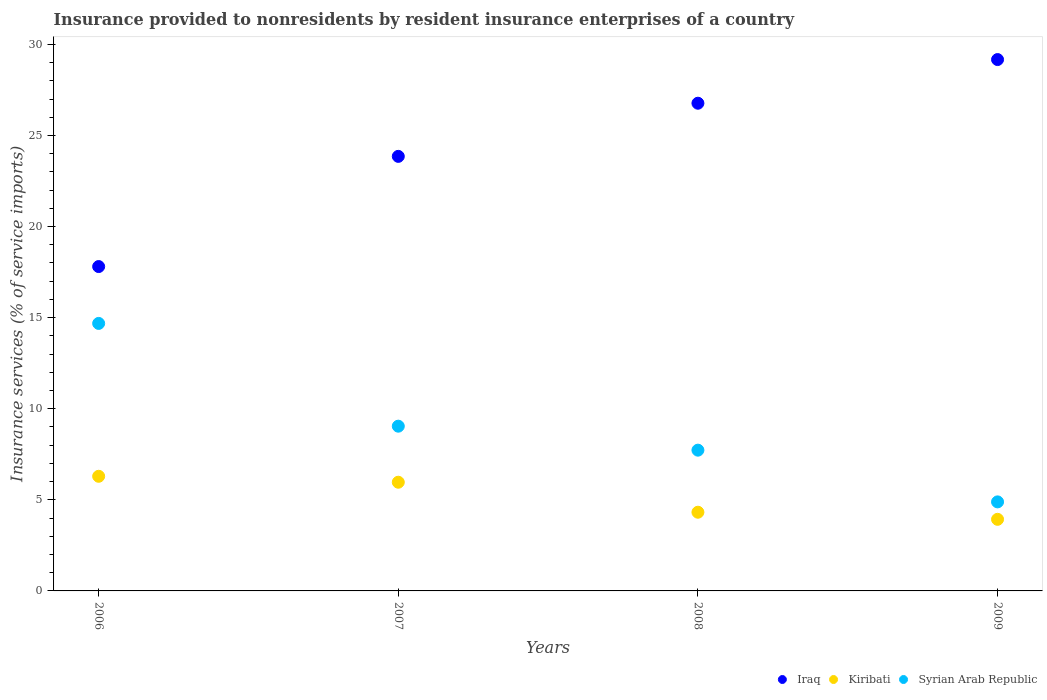How many different coloured dotlines are there?
Keep it short and to the point. 3. What is the insurance provided to nonresidents in Iraq in 2009?
Give a very brief answer. 29.16. Across all years, what is the maximum insurance provided to nonresidents in Syrian Arab Republic?
Make the answer very short. 14.68. Across all years, what is the minimum insurance provided to nonresidents in Iraq?
Ensure brevity in your answer.  17.8. In which year was the insurance provided to nonresidents in Kiribati minimum?
Your answer should be very brief. 2009. What is the total insurance provided to nonresidents in Syrian Arab Republic in the graph?
Provide a short and direct response. 36.34. What is the difference between the insurance provided to nonresidents in Kiribati in 2007 and that in 2008?
Provide a succinct answer. 1.65. What is the difference between the insurance provided to nonresidents in Kiribati in 2007 and the insurance provided to nonresidents in Syrian Arab Republic in 2009?
Provide a succinct answer. 1.08. What is the average insurance provided to nonresidents in Kiribati per year?
Offer a terse response. 5.13. In the year 2006, what is the difference between the insurance provided to nonresidents in Iraq and insurance provided to nonresidents in Syrian Arab Republic?
Your response must be concise. 3.12. What is the ratio of the insurance provided to nonresidents in Kiribati in 2006 to that in 2007?
Offer a terse response. 1.05. Is the insurance provided to nonresidents in Kiribati in 2006 less than that in 2009?
Provide a succinct answer. No. What is the difference between the highest and the second highest insurance provided to nonresidents in Kiribati?
Offer a terse response. 0.33. What is the difference between the highest and the lowest insurance provided to nonresidents in Kiribati?
Keep it short and to the point. 2.36. In how many years, is the insurance provided to nonresidents in Iraq greater than the average insurance provided to nonresidents in Iraq taken over all years?
Ensure brevity in your answer.  2. Is it the case that in every year, the sum of the insurance provided to nonresidents in Iraq and insurance provided to nonresidents in Kiribati  is greater than the insurance provided to nonresidents in Syrian Arab Republic?
Give a very brief answer. Yes. Does the insurance provided to nonresidents in Iraq monotonically increase over the years?
Ensure brevity in your answer.  Yes. How many years are there in the graph?
Keep it short and to the point. 4. Where does the legend appear in the graph?
Offer a very short reply. Bottom right. What is the title of the graph?
Your response must be concise. Insurance provided to nonresidents by resident insurance enterprises of a country. What is the label or title of the Y-axis?
Your response must be concise. Insurance services (% of service imports). What is the Insurance services (% of service imports) of Iraq in 2006?
Make the answer very short. 17.8. What is the Insurance services (% of service imports) in Kiribati in 2006?
Give a very brief answer. 6.29. What is the Insurance services (% of service imports) of Syrian Arab Republic in 2006?
Your answer should be very brief. 14.68. What is the Insurance services (% of service imports) of Iraq in 2007?
Make the answer very short. 23.85. What is the Insurance services (% of service imports) in Kiribati in 2007?
Give a very brief answer. 5.97. What is the Insurance services (% of service imports) in Syrian Arab Republic in 2007?
Your response must be concise. 9.04. What is the Insurance services (% of service imports) in Iraq in 2008?
Make the answer very short. 26.77. What is the Insurance services (% of service imports) of Kiribati in 2008?
Your response must be concise. 4.32. What is the Insurance services (% of service imports) of Syrian Arab Republic in 2008?
Keep it short and to the point. 7.73. What is the Insurance services (% of service imports) of Iraq in 2009?
Make the answer very short. 29.16. What is the Insurance services (% of service imports) of Kiribati in 2009?
Make the answer very short. 3.93. What is the Insurance services (% of service imports) of Syrian Arab Republic in 2009?
Provide a short and direct response. 4.89. Across all years, what is the maximum Insurance services (% of service imports) of Iraq?
Give a very brief answer. 29.16. Across all years, what is the maximum Insurance services (% of service imports) in Kiribati?
Provide a short and direct response. 6.29. Across all years, what is the maximum Insurance services (% of service imports) in Syrian Arab Republic?
Your answer should be compact. 14.68. Across all years, what is the minimum Insurance services (% of service imports) in Iraq?
Provide a short and direct response. 17.8. Across all years, what is the minimum Insurance services (% of service imports) of Kiribati?
Ensure brevity in your answer.  3.93. Across all years, what is the minimum Insurance services (% of service imports) of Syrian Arab Republic?
Make the answer very short. 4.89. What is the total Insurance services (% of service imports) of Iraq in the graph?
Make the answer very short. 97.59. What is the total Insurance services (% of service imports) of Kiribati in the graph?
Your answer should be very brief. 20.51. What is the total Insurance services (% of service imports) in Syrian Arab Republic in the graph?
Your answer should be compact. 36.34. What is the difference between the Insurance services (% of service imports) of Iraq in 2006 and that in 2007?
Your answer should be compact. -6.05. What is the difference between the Insurance services (% of service imports) in Kiribati in 2006 and that in 2007?
Your answer should be very brief. 0.33. What is the difference between the Insurance services (% of service imports) in Syrian Arab Republic in 2006 and that in 2007?
Provide a short and direct response. 5.64. What is the difference between the Insurance services (% of service imports) in Iraq in 2006 and that in 2008?
Give a very brief answer. -8.97. What is the difference between the Insurance services (% of service imports) in Kiribati in 2006 and that in 2008?
Give a very brief answer. 1.97. What is the difference between the Insurance services (% of service imports) of Syrian Arab Republic in 2006 and that in 2008?
Keep it short and to the point. 6.96. What is the difference between the Insurance services (% of service imports) in Iraq in 2006 and that in 2009?
Your response must be concise. -11.36. What is the difference between the Insurance services (% of service imports) of Kiribati in 2006 and that in 2009?
Provide a succinct answer. 2.36. What is the difference between the Insurance services (% of service imports) in Syrian Arab Republic in 2006 and that in 2009?
Keep it short and to the point. 9.8. What is the difference between the Insurance services (% of service imports) in Iraq in 2007 and that in 2008?
Make the answer very short. -2.92. What is the difference between the Insurance services (% of service imports) in Kiribati in 2007 and that in 2008?
Your response must be concise. 1.65. What is the difference between the Insurance services (% of service imports) of Syrian Arab Republic in 2007 and that in 2008?
Offer a very short reply. 1.32. What is the difference between the Insurance services (% of service imports) in Iraq in 2007 and that in 2009?
Offer a very short reply. -5.31. What is the difference between the Insurance services (% of service imports) of Kiribati in 2007 and that in 2009?
Provide a succinct answer. 2.04. What is the difference between the Insurance services (% of service imports) of Syrian Arab Republic in 2007 and that in 2009?
Your answer should be compact. 4.15. What is the difference between the Insurance services (% of service imports) in Iraq in 2008 and that in 2009?
Provide a short and direct response. -2.4. What is the difference between the Insurance services (% of service imports) in Kiribati in 2008 and that in 2009?
Offer a very short reply. 0.39. What is the difference between the Insurance services (% of service imports) in Syrian Arab Republic in 2008 and that in 2009?
Your answer should be very brief. 2.84. What is the difference between the Insurance services (% of service imports) of Iraq in 2006 and the Insurance services (% of service imports) of Kiribati in 2007?
Make the answer very short. 11.84. What is the difference between the Insurance services (% of service imports) of Iraq in 2006 and the Insurance services (% of service imports) of Syrian Arab Republic in 2007?
Offer a very short reply. 8.76. What is the difference between the Insurance services (% of service imports) in Kiribati in 2006 and the Insurance services (% of service imports) in Syrian Arab Republic in 2007?
Your answer should be very brief. -2.75. What is the difference between the Insurance services (% of service imports) in Iraq in 2006 and the Insurance services (% of service imports) in Kiribati in 2008?
Your answer should be compact. 13.48. What is the difference between the Insurance services (% of service imports) of Iraq in 2006 and the Insurance services (% of service imports) of Syrian Arab Republic in 2008?
Offer a terse response. 10.08. What is the difference between the Insurance services (% of service imports) in Kiribati in 2006 and the Insurance services (% of service imports) in Syrian Arab Republic in 2008?
Your response must be concise. -1.43. What is the difference between the Insurance services (% of service imports) of Iraq in 2006 and the Insurance services (% of service imports) of Kiribati in 2009?
Provide a succinct answer. 13.87. What is the difference between the Insurance services (% of service imports) in Iraq in 2006 and the Insurance services (% of service imports) in Syrian Arab Republic in 2009?
Make the answer very short. 12.92. What is the difference between the Insurance services (% of service imports) in Kiribati in 2006 and the Insurance services (% of service imports) in Syrian Arab Republic in 2009?
Keep it short and to the point. 1.4. What is the difference between the Insurance services (% of service imports) of Iraq in 2007 and the Insurance services (% of service imports) of Kiribati in 2008?
Provide a succinct answer. 19.53. What is the difference between the Insurance services (% of service imports) in Iraq in 2007 and the Insurance services (% of service imports) in Syrian Arab Republic in 2008?
Provide a succinct answer. 16.13. What is the difference between the Insurance services (% of service imports) in Kiribati in 2007 and the Insurance services (% of service imports) in Syrian Arab Republic in 2008?
Keep it short and to the point. -1.76. What is the difference between the Insurance services (% of service imports) of Iraq in 2007 and the Insurance services (% of service imports) of Kiribati in 2009?
Provide a short and direct response. 19.92. What is the difference between the Insurance services (% of service imports) of Iraq in 2007 and the Insurance services (% of service imports) of Syrian Arab Republic in 2009?
Your answer should be very brief. 18.96. What is the difference between the Insurance services (% of service imports) in Kiribati in 2007 and the Insurance services (% of service imports) in Syrian Arab Republic in 2009?
Your answer should be compact. 1.08. What is the difference between the Insurance services (% of service imports) in Iraq in 2008 and the Insurance services (% of service imports) in Kiribati in 2009?
Keep it short and to the point. 22.84. What is the difference between the Insurance services (% of service imports) in Iraq in 2008 and the Insurance services (% of service imports) in Syrian Arab Republic in 2009?
Ensure brevity in your answer.  21.88. What is the difference between the Insurance services (% of service imports) of Kiribati in 2008 and the Insurance services (% of service imports) of Syrian Arab Republic in 2009?
Offer a very short reply. -0.57. What is the average Insurance services (% of service imports) of Iraq per year?
Give a very brief answer. 24.4. What is the average Insurance services (% of service imports) in Kiribati per year?
Keep it short and to the point. 5.13. What is the average Insurance services (% of service imports) of Syrian Arab Republic per year?
Provide a succinct answer. 9.08. In the year 2006, what is the difference between the Insurance services (% of service imports) in Iraq and Insurance services (% of service imports) in Kiribati?
Keep it short and to the point. 11.51. In the year 2006, what is the difference between the Insurance services (% of service imports) of Iraq and Insurance services (% of service imports) of Syrian Arab Republic?
Your response must be concise. 3.12. In the year 2006, what is the difference between the Insurance services (% of service imports) in Kiribati and Insurance services (% of service imports) in Syrian Arab Republic?
Give a very brief answer. -8.39. In the year 2007, what is the difference between the Insurance services (% of service imports) of Iraq and Insurance services (% of service imports) of Kiribati?
Give a very brief answer. 17.89. In the year 2007, what is the difference between the Insurance services (% of service imports) in Iraq and Insurance services (% of service imports) in Syrian Arab Republic?
Offer a terse response. 14.81. In the year 2007, what is the difference between the Insurance services (% of service imports) in Kiribati and Insurance services (% of service imports) in Syrian Arab Republic?
Provide a short and direct response. -3.08. In the year 2008, what is the difference between the Insurance services (% of service imports) of Iraq and Insurance services (% of service imports) of Kiribati?
Provide a short and direct response. 22.45. In the year 2008, what is the difference between the Insurance services (% of service imports) in Iraq and Insurance services (% of service imports) in Syrian Arab Republic?
Ensure brevity in your answer.  19.04. In the year 2008, what is the difference between the Insurance services (% of service imports) in Kiribati and Insurance services (% of service imports) in Syrian Arab Republic?
Make the answer very short. -3.41. In the year 2009, what is the difference between the Insurance services (% of service imports) in Iraq and Insurance services (% of service imports) in Kiribati?
Your answer should be very brief. 25.23. In the year 2009, what is the difference between the Insurance services (% of service imports) of Iraq and Insurance services (% of service imports) of Syrian Arab Republic?
Offer a very short reply. 24.28. In the year 2009, what is the difference between the Insurance services (% of service imports) in Kiribati and Insurance services (% of service imports) in Syrian Arab Republic?
Make the answer very short. -0.96. What is the ratio of the Insurance services (% of service imports) in Iraq in 2006 to that in 2007?
Provide a short and direct response. 0.75. What is the ratio of the Insurance services (% of service imports) in Kiribati in 2006 to that in 2007?
Offer a terse response. 1.05. What is the ratio of the Insurance services (% of service imports) in Syrian Arab Republic in 2006 to that in 2007?
Offer a very short reply. 1.62. What is the ratio of the Insurance services (% of service imports) in Iraq in 2006 to that in 2008?
Provide a succinct answer. 0.67. What is the ratio of the Insurance services (% of service imports) of Kiribati in 2006 to that in 2008?
Offer a terse response. 1.46. What is the ratio of the Insurance services (% of service imports) of Syrian Arab Republic in 2006 to that in 2008?
Ensure brevity in your answer.  1.9. What is the ratio of the Insurance services (% of service imports) in Iraq in 2006 to that in 2009?
Your answer should be compact. 0.61. What is the ratio of the Insurance services (% of service imports) of Kiribati in 2006 to that in 2009?
Give a very brief answer. 1.6. What is the ratio of the Insurance services (% of service imports) of Syrian Arab Republic in 2006 to that in 2009?
Provide a short and direct response. 3. What is the ratio of the Insurance services (% of service imports) of Iraq in 2007 to that in 2008?
Give a very brief answer. 0.89. What is the ratio of the Insurance services (% of service imports) of Kiribati in 2007 to that in 2008?
Offer a very short reply. 1.38. What is the ratio of the Insurance services (% of service imports) in Syrian Arab Republic in 2007 to that in 2008?
Keep it short and to the point. 1.17. What is the ratio of the Insurance services (% of service imports) of Iraq in 2007 to that in 2009?
Keep it short and to the point. 0.82. What is the ratio of the Insurance services (% of service imports) in Kiribati in 2007 to that in 2009?
Make the answer very short. 1.52. What is the ratio of the Insurance services (% of service imports) in Syrian Arab Republic in 2007 to that in 2009?
Your answer should be compact. 1.85. What is the ratio of the Insurance services (% of service imports) in Iraq in 2008 to that in 2009?
Offer a very short reply. 0.92. What is the ratio of the Insurance services (% of service imports) in Kiribati in 2008 to that in 2009?
Offer a terse response. 1.1. What is the ratio of the Insurance services (% of service imports) of Syrian Arab Republic in 2008 to that in 2009?
Your answer should be very brief. 1.58. What is the difference between the highest and the second highest Insurance services (% of service imports) in Iraq?
Make the answer very short. 2.4. What is the difference between the highest and the second highest Insurance services (% of service imports) of Kiribati?
Your answer should be very brief. 0.33. What is the difference between the highest and the second highest Insurance services (% of service imports) of Syrian Arab Republic?
Provide a short and direct response. 5.64. What is the difference between the highest and the lowest Insurance services (% of service imports) of Iraq?
Your answer should be very brief. 11.36. What is the difference between the highest and the lowest Insurance services (% of service imports) in Kiribati?
Make the answer very short. 2.36. What is the difference between the highest and the lowest Insurance services (% of service imports) of Syrian Arab Republic?
Your answer should be very brief. 9.8. 